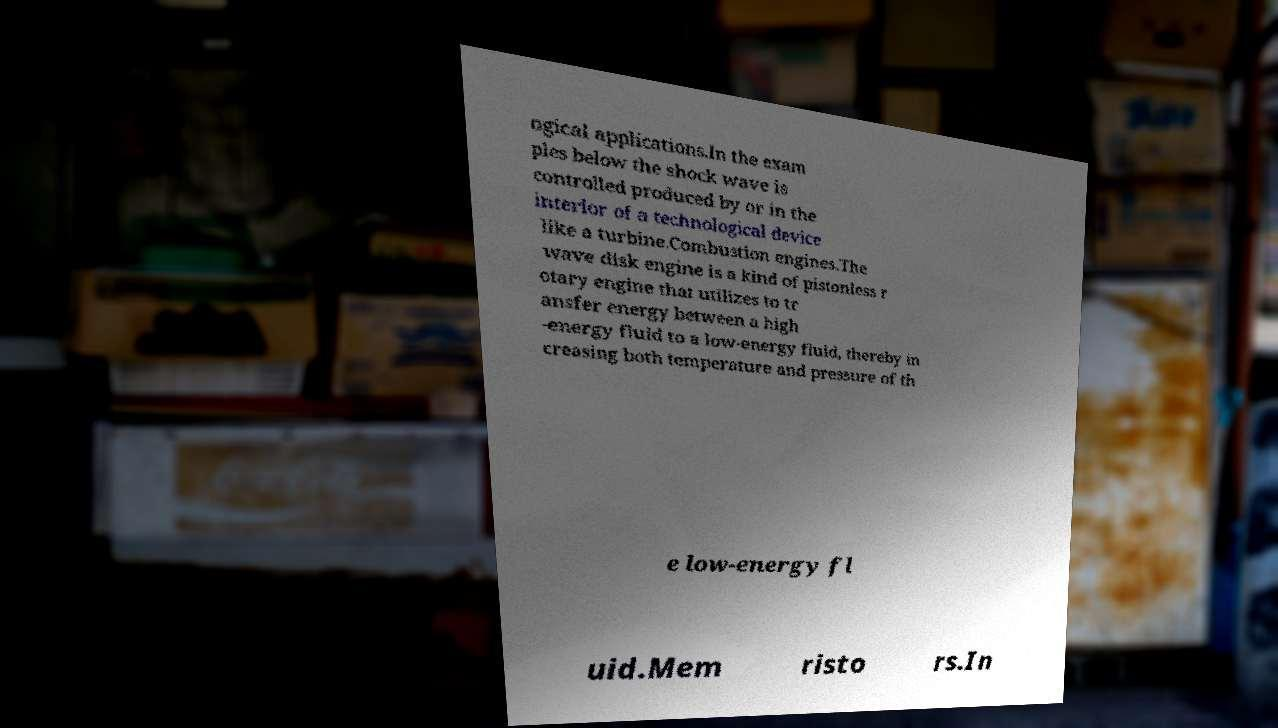Please identify and transcribe the text found in this image. ogical applications.In the exam ples below the shock wave is controlled produced by or in the interior of a technological device like a turbine.Combustion engines.The wave disk engine is a kind of pistonless r otary engine that utilizes to tr ansfer energy between a high -energy fluid to a low-energy fluid, thereby in creasing both temperature and pressure of th e low-energy fl uid.Mem risto rs.In 